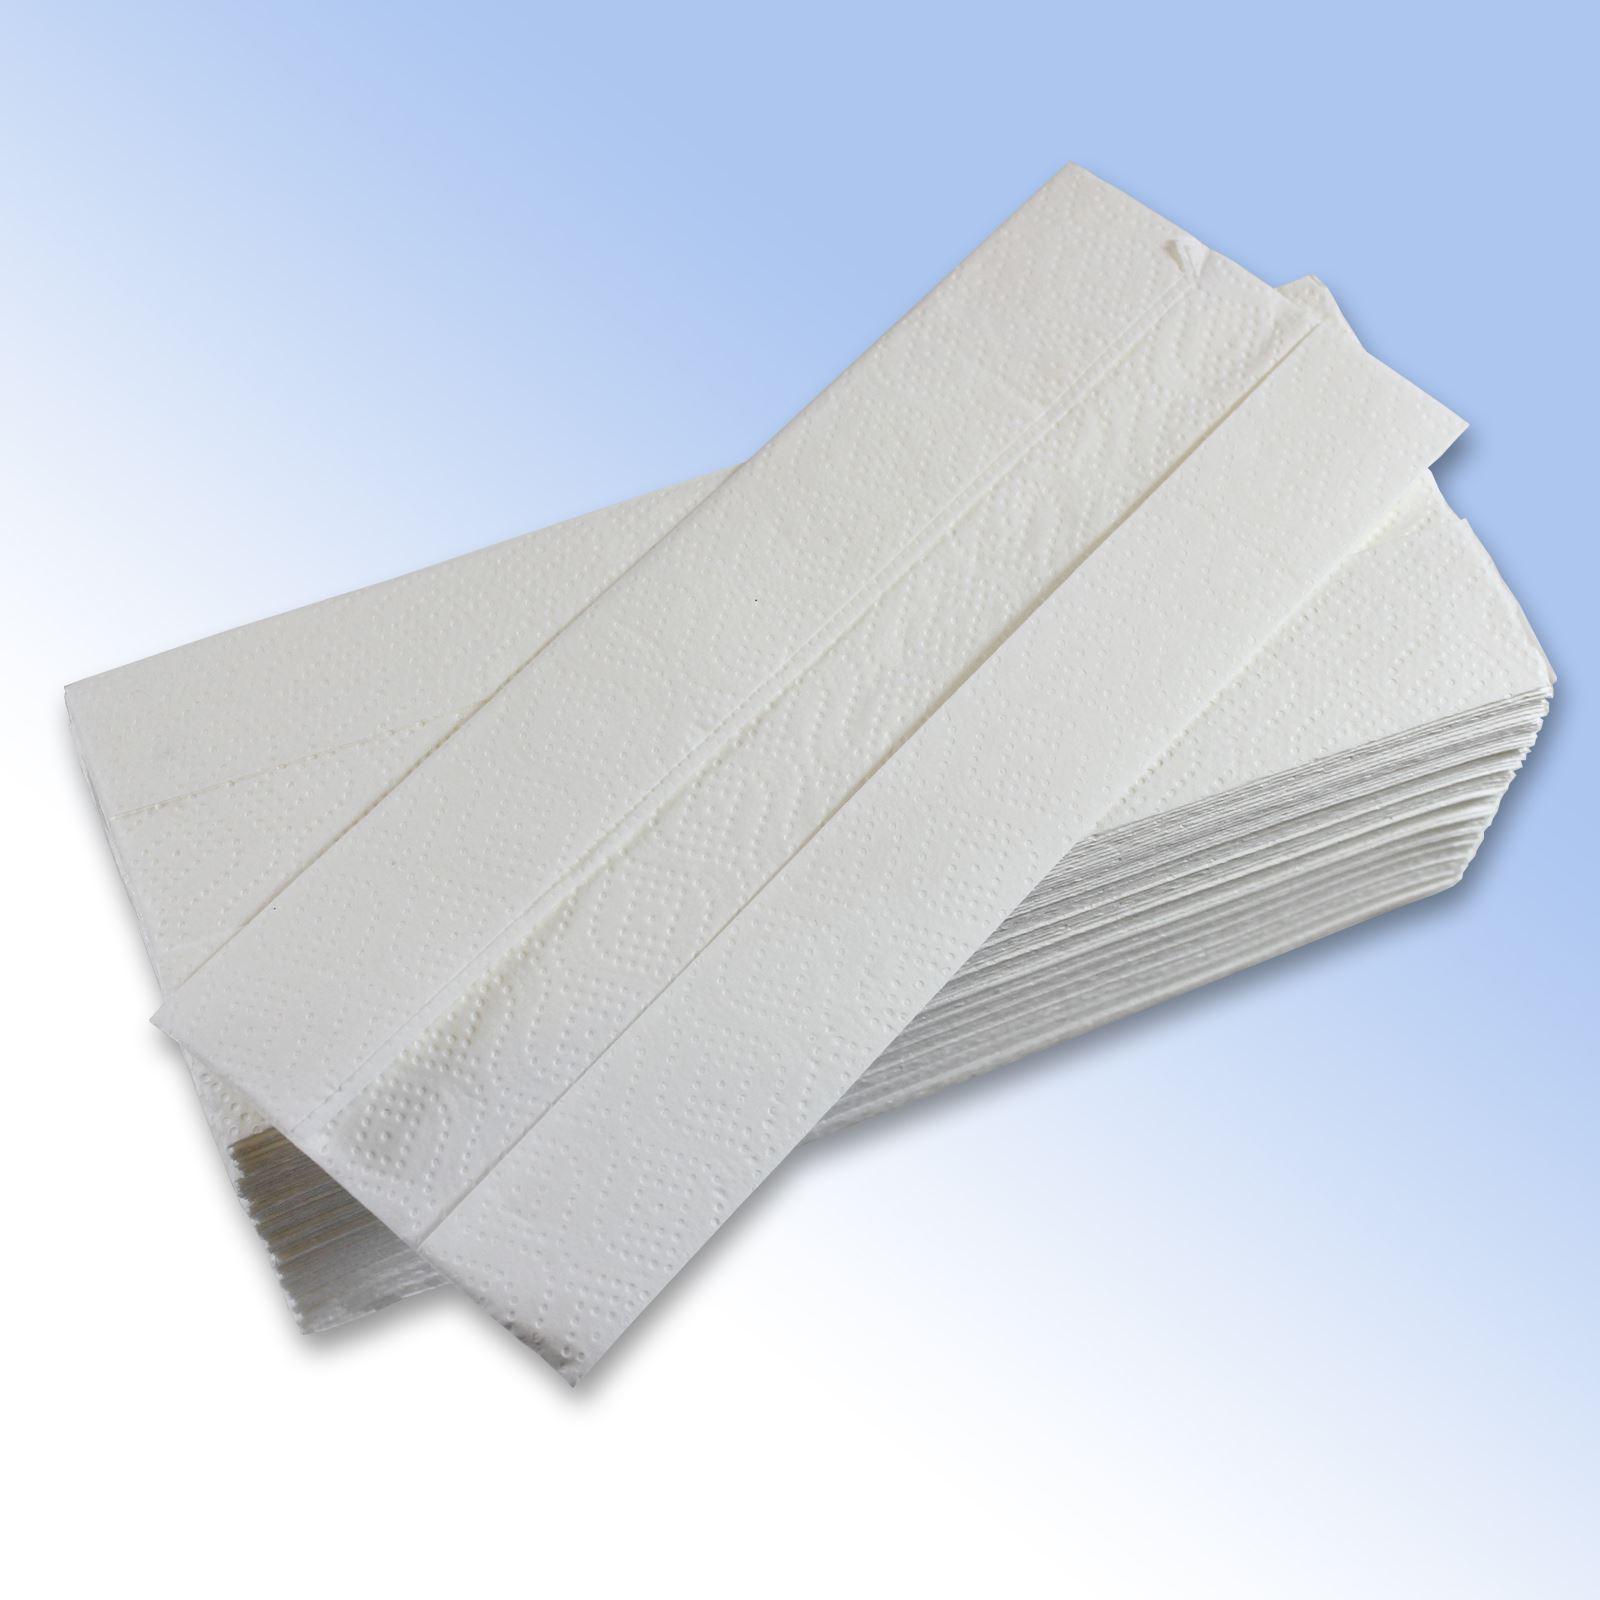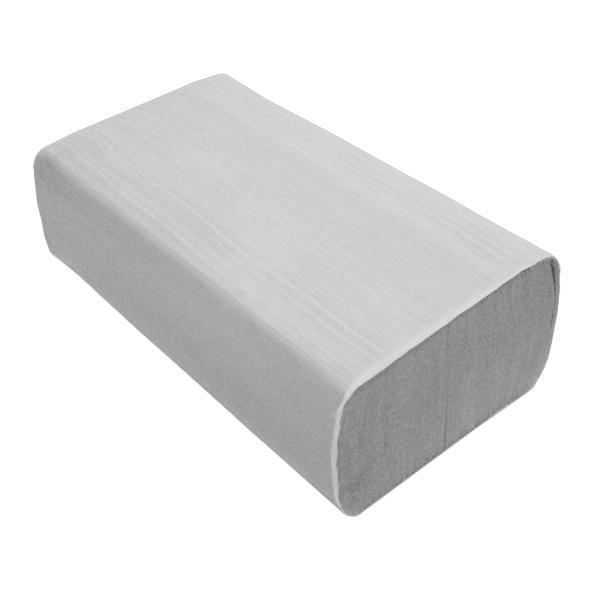The first image is the image on the left, the second image is the image on the right. For the images shown, is this caption "The right image contains one wrapped pack of folded paper towels, and the left image shows a single folded towel that is not aligned with a neat stack." true? Answer yes or no. Yes. The first image is the image on the left, the second image is the image on the right. For the images displayed, is the sentence "Some paper towels are wrapped in paper." factually correct? Answer yes or no. Yes. 